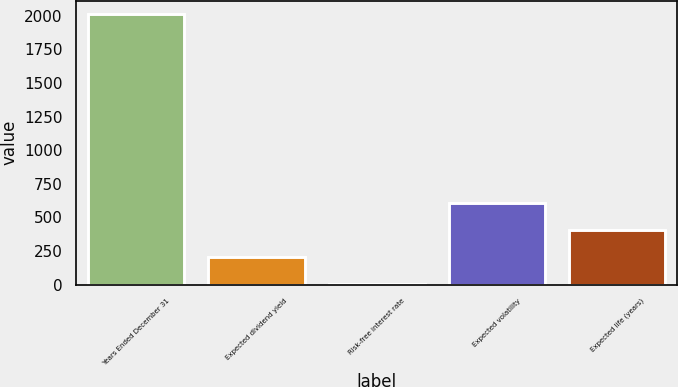<chart> <loc_0><loc_0><loc_500><loc_500><bar_chart><fcel>Years Ended December 31<fcel>Expected dividend yield<fcel>Risk-free interest rate<fcel>Expected volatility<fcel>Expected life (years)<nl><fcel>2011<fcel>203.35<fcel>2.5<fcel>605.05<fcel>404.2<nl></chart> 